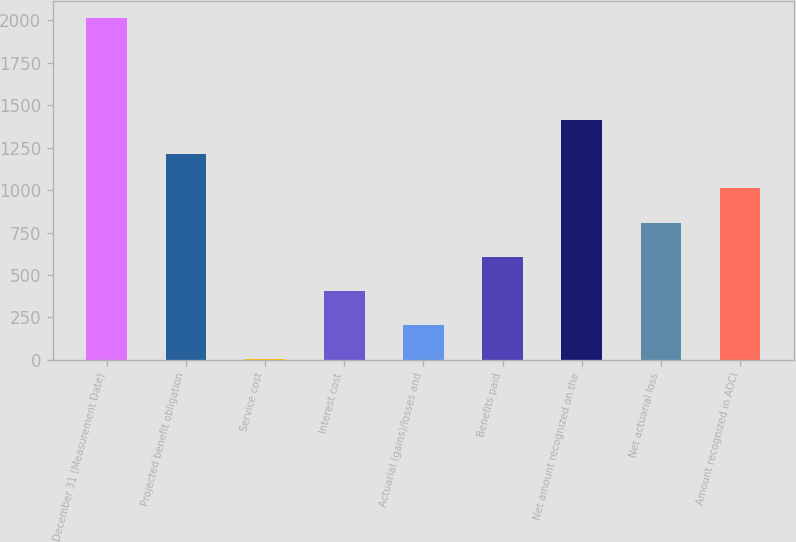<chart> <loc_0><loc_0><loc_500><loc_500><bar_chart><fcel>December 31 (Measurement Date)<fcel>Projected benefit obligation<fcel>Service cost<fcel>Interest cost<fcel>Actuarial (gains)/losses and<fcel>Benefits paid<fcel>Net amount recognized on the<fcel>Net actuarial loss<fcel>Amount recognized in AOCI<nl><fcel>2016<fcel>1210.8<fcel>3<fcel>405.6<fcel>204.3<fcel>606.9<fcel>1412.1<fcel>808.2<fcel>1009.5<nl></chart> 